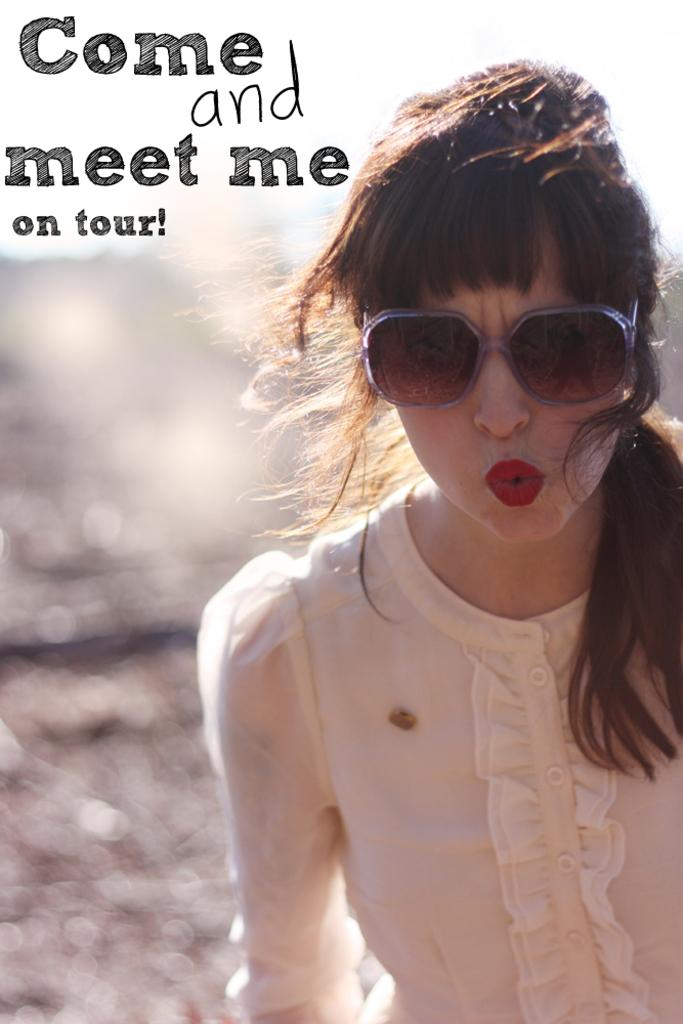What can be seen on the poster in the picture? There is a poster in the picture, but the details are not mentioned in the facts. What accessory is the woman wearing in the picture? The woman is wearing sunglasses in the picture. What can be read or seen in written form in the picture? There is text visible in the picture. How would you describe the background of the picture? The background of the picture appears blurry. How many lizards are crawling on the poster in the picture? There is no mention of lizards in the provided facts, so we cannot determine if any are present in the image. 